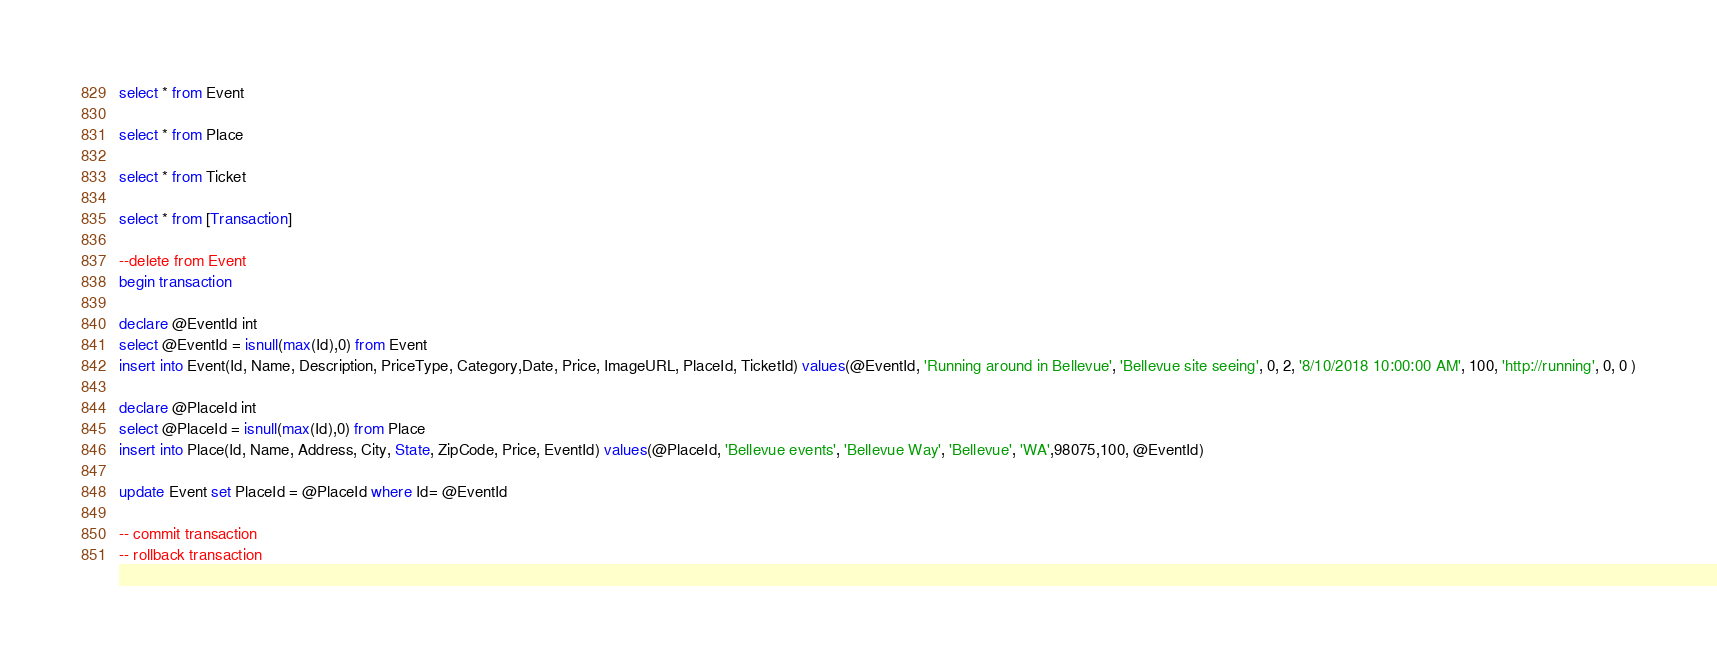Convert code to text. <code><loc_0><loc_0><loc_500><loc_500><_SQL_>select * from Event

select * from Place

select * from Ticket

select * from [Transaction]

--delete from Event
begin transaction

declare @EventId int
select @EventId = isnull(max(Id),0) from Event
insert into Event(Id, Name, Description, PriceType, Category,Date, Price, ImageURL, PlaceId, TicketId) values(@EventId, 'Running around in Bellevue', 'Bellevue site seeing', 0, 2, '8/10/2018 10:00:00 AM', 100, 'http://running', 0, 0 )

declare @PlaceId int
select @PlaceId = isnull(max(Id),0) from Place
insert into Place(Id, Name, Address, City, State, ZipCode, Price, EventId) values(@PlaceId, 'Bellevue events', 'Bellevue Way', 'Bellevue', 'WA',98075,100, @EventId)

update Event set PlaceId = @PlaceId where Id= @EventId

-- commit transaction
-- rollback transaction
</code> 